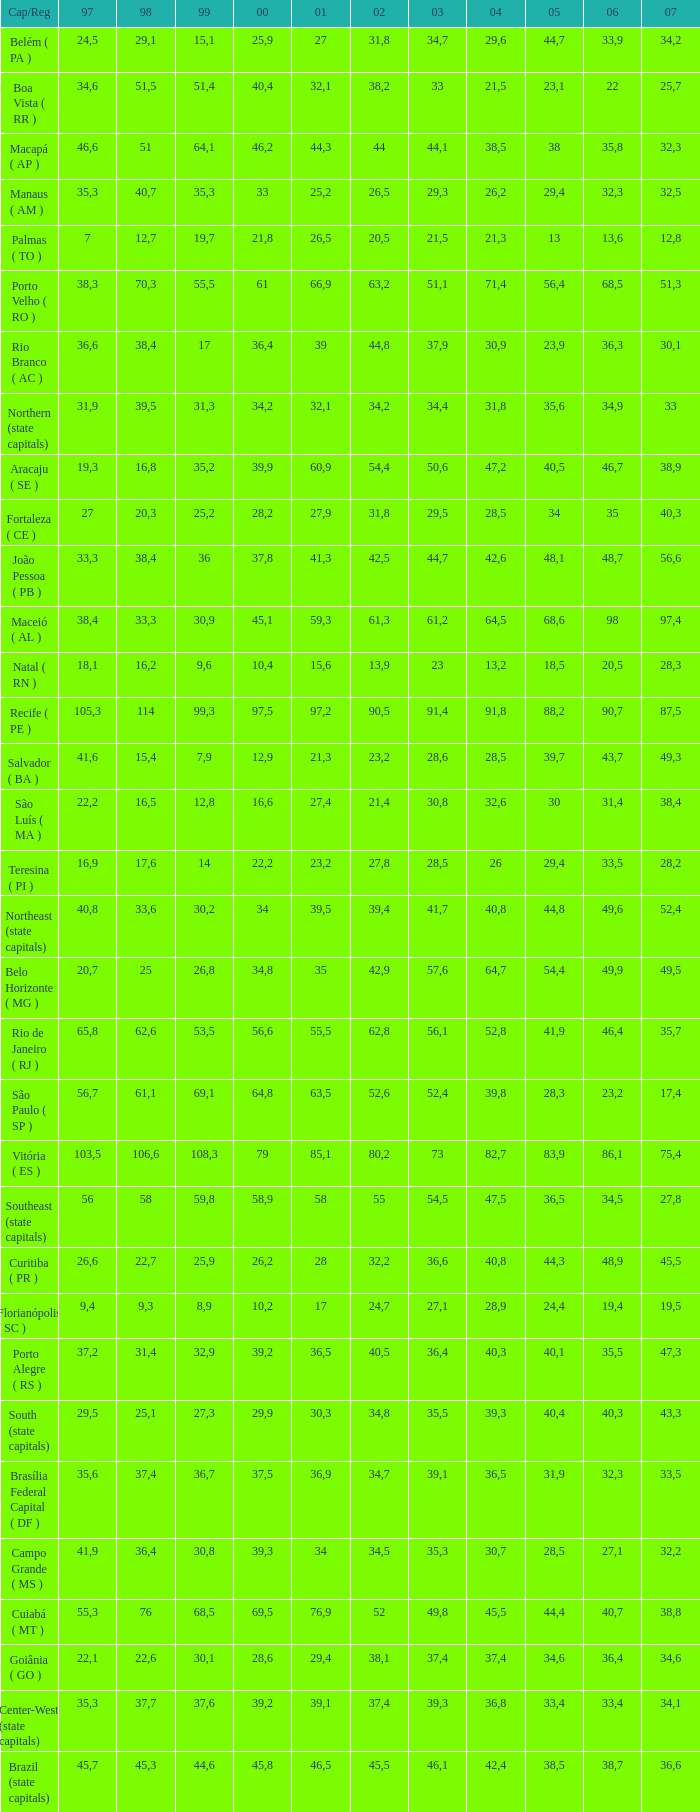What is the average 2000 that has a 1997 greater than 34,6, a 2006 greater than 38,7, and a 2998 less than 76? 41.92. 